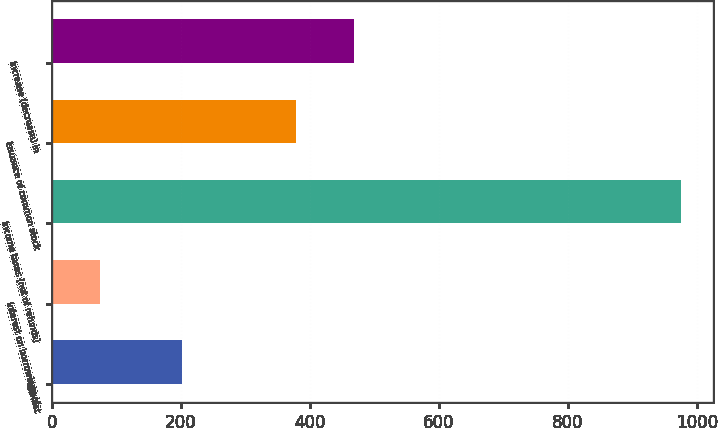Convert chart to OTSL. <chart><loc_0><loc_0><loc_500><loc_500><bar_chart><fcel>Interest<fcel>Interest on borrowings of<fcel>Income taxes (net of refunds)<fcel>Issuance of common stock<fcel>Increase (decrease) in<nl><fcel>201<fcel>75<fcel>976<fcel>378<fcel>468.1<nl></chart> 